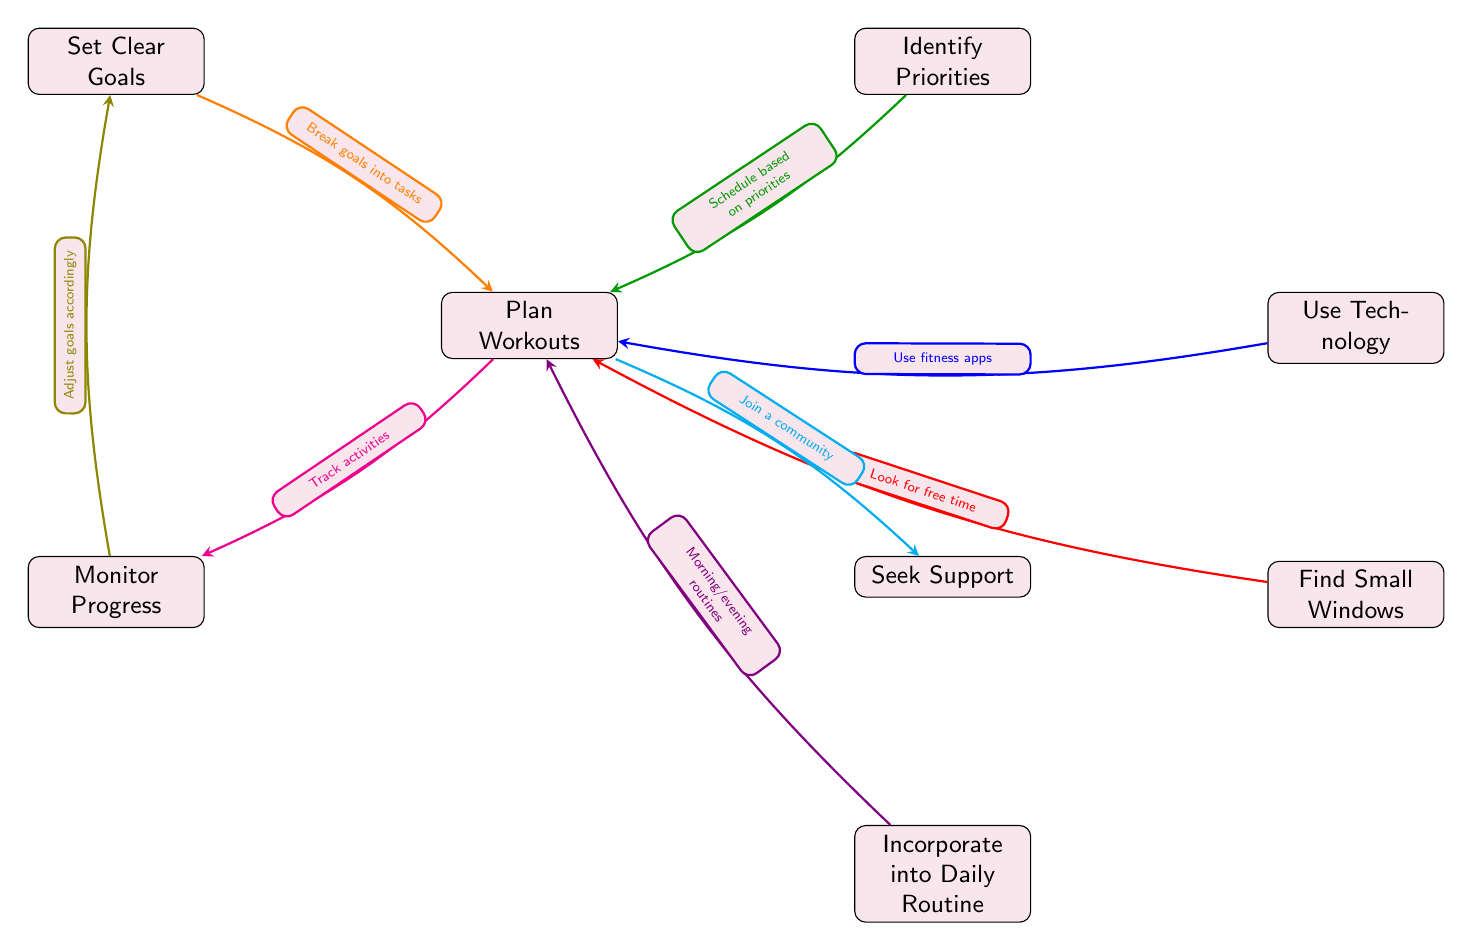What is the first node in the diagram? The first node in the diagram is "Set Clear Goals." It is the topmost node from which the other nodes branch out.
Answer: Set Clear Goals How many nodes are present in the diagram? By counting the individual nodes displayed, there are a total of 8 nodes in the diagram that represent various time management strategies.
Answer: 8 What does the orange arrow represent? The orange arrow connects the nodes "Set Clear Goals" and "Plan Workouts," indicating the relationship that breaking goals into tasks helps in planning workouts.
Answer: Break goals into tasks Which node is linked to "Plan Workouts" by two different nodes? The node "Plan Workouts" is connected to "Set Clear Goals" and "Seek Support," representing different strategies that are aimed at facilitating workout planning.
Answer: Set Clear Goals What flow leads to "Monitor Progress"? The flow leads to "Monitor Progress" from "Plan Workouts," showing that after planning, the next step involves tracking activities related to those workout plans.
Answer: Track activities How does "Incorporate into Daily Routine" relate to "Plan Workouts"? "Incorporate into Daily Routine" is linked to "Plan Workouts" via the "Find Small Windows" node, suggesting that finding free time allows one to incorporate workouts into their daily schedule effectively.
Answer: Morning/evening routines Which two nodes provide actionable inputs to "Plan Workouts"? The nodes "Identify Priorities" and "Use Technology" both provide actionable inputs to "Plan Workouts," highlighting the importance of prioritization and technology in effectively scheduling workouts.
Answer: Identify Priorities, Use Technology What node suggests seeking community help? The node "Seek Support" suggests the strategy of joining a community to assist with planning and maintaining a workout schedule.
Answer: Join a community 